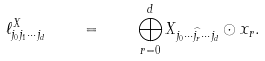Convert formula to latex. <formula><loc_0><loc_0><loc_500><loc_500>\ell ^ { X } _ { j _ { 0 } j _ { 1 } \cdots j _ { d } } \quad = \quad \bigoplus _ { r = 0 } ^ { d } X _ { j _ { 0 } \cdots \widehat { j _ { r } } \cdots j _ { d } } \odot x _ { r } .</formula> 